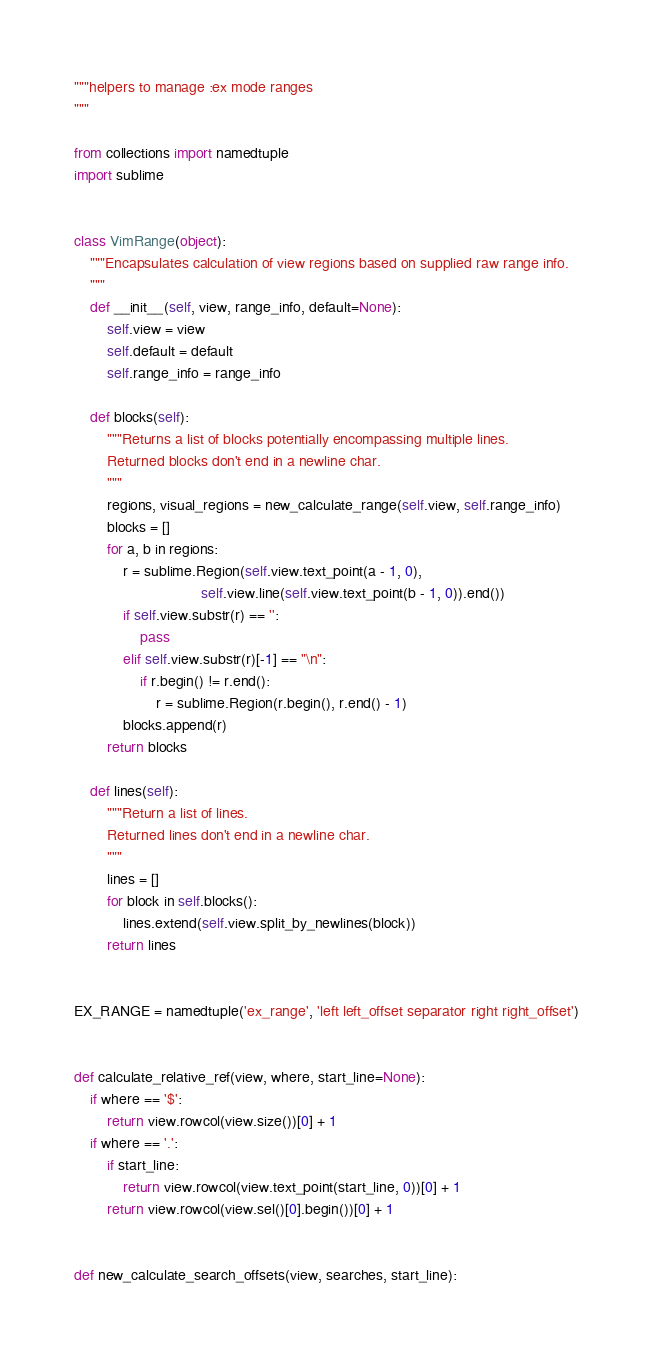Convert code to text. <code><loc_0><loc_0><loc_500><loc_500><_Python_>"""helpers to manage :ex mode ranges
"""

from collections import namedtuple
import sublime


class VimRange(object):
    """Encapsulates calculation of view regions based on supplied raw range info.
    """
    def __init__(self, view, range_info, default=None):
        self.view = view
        self.default = default
        self.range_info = range_info

    def blocks(self):
        """Returns a list of blocks potentially encompassing multiple lines.
        Returned blocks don't end in a newline char.
        """
        regions, visual_regions = new_calculate_range(self.view, self.range_info)
        blocks = []
        for a, b in regions:
            r = sublime.Region(self.view.text_point(a - 1, 0),
                               self.view.line(self.view.text_point(b - 1, 0)).end())
            if self.view.substr(r) == '':
                pass
            elif self.view.substr(r)[-1] == "\n":
                if r.begin() != r.end():
                    r = sublime.Region(r.begin(), r.end() - 1)
            blocks.append(r)
        return blocks

    def lines(self):
        """Return a list of lines.
        Returned lines don't end in a newline char.
        """
        lines = []
        for block in self.blocks():
            lines.extend(self.view.split_by_newlines(block))
        return lines


EX_RANGE = namedtuple('ex_range', 'left left_offset separator right right_offset')


def calculate_relative_ref(view, where, start_line=None):
    if where == '$':
        return view.rowcol(view.size())[0] + 1
    if where == '.':
        if start_line:
            return view.rowcol(view.text_point(start_line, 0))[0] + 1
        return view.rowcol(view.sel()[0].begin())[0] + 1


def new_calculate_search_offsets(view, searches, start_line):</code> 